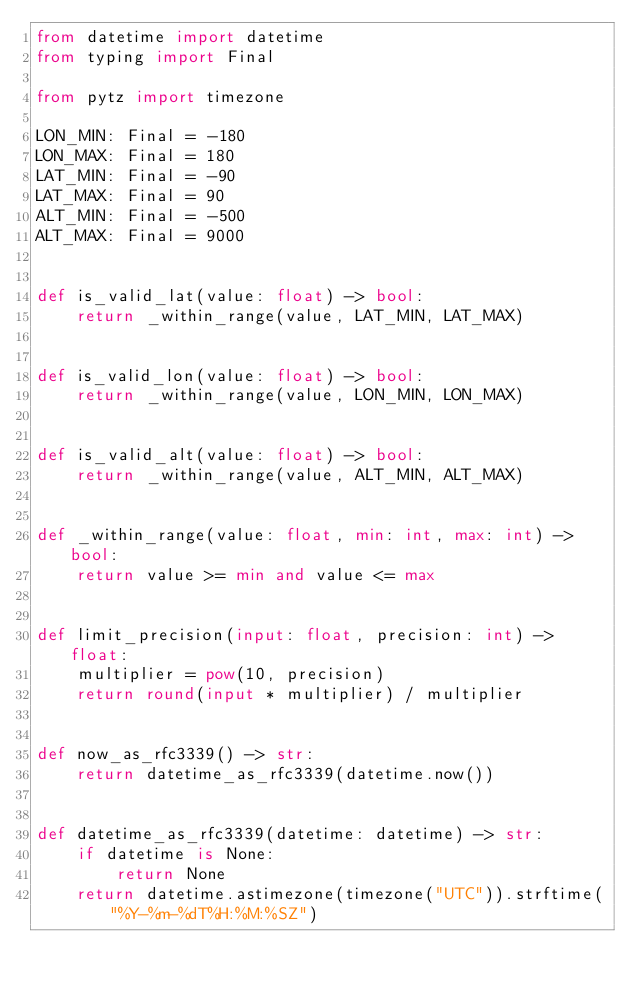Convert code to text. <code><loc_0><loc_0><loc_500><loc_500><_Python_>from datetime import datetime
from typing import Final

from pytz import timezone

LON_MIN: Final = -180
LON_MAX: Final = 180
LAT_MIN: Final = -90
LAT_MAX: Final = 90
ALT_MIN: Final = -500
ALT_MAX: Final = 9000


def is_valid_lat(value: float) -> bool:
    return _within_range(value, LAT_MIN, LAT_MAX)


def is_valid_lon(value: float) -> bool:
    return _within_range(value, LON_MIN, LON_MAX)


def is_valid_alt(value: float) -> bool:
    return _within_range(value, ALT_MIN, ALT_MAX)


def _within_range(value: float, min: int, max: int) -> bool:
    return value >= min and value <= max


def limit_precision(input: float, precision: int) -> float:
    multiplier = pow(10, precision)
    return round(input * multiplier) / multiplier


def now_as_rfc3339() -> str:
    return datetime_as_rfc3339(datetime.now())


def datetime_as_rfc3339(datetime: datetime) -> str:
    if datetime is None:
        return None
    return datetime.astimezone(timezone("UTC")).strftime("%Y-%m-%dT%H:%M:%SZ")
</code> 